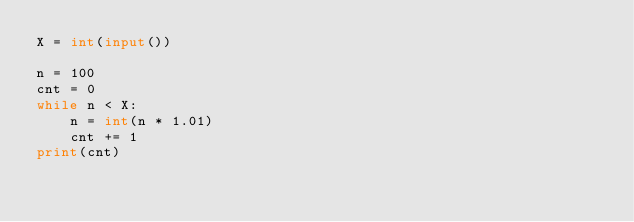<code> <loc_0><loc_0><loc_500><loc_500><_Python_>X = int(input())

n = 100
cnt = 0
while n < X:
    n = int(n * 1.01)
    cnt += 1
print(cnt)</code> 